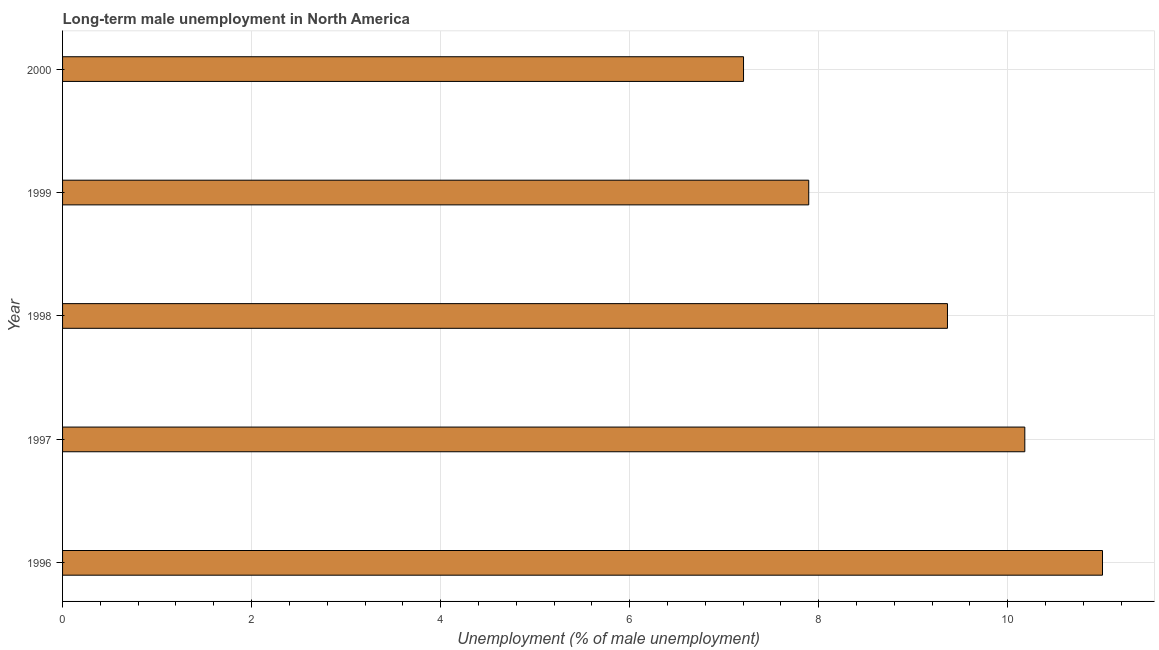Does the graph contain any zero values?
Your answer should be compact. No. What is the title of the graph?
Make the answer very short. Long-term male unemployment in North America. What is the label or title of the X-axis?
Ensure brevity in your answer.  Unemployment (% of male unemployment). What is the label or title of the Y-axis?
Offer a very short reply. Year. What is the long-term male unemployment in 1998?
Your response must be concise. 9.36. Across all years, what is the maximum long-term male unemployment?
Your answer should be compact. 11. Across all years, what is the minimum long-term male unemployment?
Offer a terse response. 7.2. In which year was the long-term male unemployment minimum?
Make the answer very short. 2000. What is the sum of the long-term male unemployment?
Offer a terse response. 45.65. What is the difference between the long-term male unemployment in 1997 and 2000?
Your answer should be very brief. 2.98. What is the average long-term male unemployment per year?
Your response must be concise. 9.13. What is the median long-term male unemployment?
Provide a short and direct response. 9.36. What is the ratio of the long-term male unemployment in 1998 to that in 2000?
Give a very brief answer. 1.3. Is the long-term male unemployment in 1996 less than that in 1997?
Provide a short and direct response. No. What is the difference between the highest and the second highest long-term male unemployment?
Make the answer very short. 0.82. In how many years, is the long-term male unemployment greater than the average long-term male unemployment taken over all years?
Give a very brief answer. 3. Are all the bars in the graph horizontal?
Offer a terse response. Yes. How many years are there in the graph?
Your answer should be very brief. 5. Are the values on the major ticks of X-axis written in scientific E-notation?
Ensure brevity in your answer.  No. What is the Unemployment (% of male unemployment) in 1996?
Offer a very short reply. 11. What is the Unemployment (% of male unemployment) of 1997?
Offer a very short reply. 10.18. What is the Unemployment (% of male unemployment) in 1998?
Your answer should be very brief. 9.36. What is the Unemployment (% of male unemployment) of 1999?
Ensure brevity in your answer.  7.89. What is the Unemployment (% of male unemployment) of 2000?
Offer a very short reply. 7.2. What is the difference between the Unemployment (% of male unemployment) in 1996 and 1997?
Your response must be concise. 0.82. What is the difference between the Unemployment (% of male unemployment) in 1996 and 1998?
Provide a short and direct response. 1.64. What is the difference between the Unemployment (% of male unemployment) in 1996 and 1999?
Give a very brief answer. 3.11. What is the difference between the Unemployment (% of male unemployment) in 1996 and 2000?
Ensure brevity in your answer.  3.8. What is the difference between the Unemployment (% of male unemployment) in 1997 and 1998?
Give a very brief answer. 0.82. What is the difference between the Unemployment (% of male unemployment) in 1997 and 1999?
Offer a very short reply. 2.29. What is the difference between the Unemployment (% of male unemployment) in 1997 and 2000?
Provide a short and direct response. 2.98. What is the difference between the Unemployment (% of male unemployment) in 1998 and 1999?
Give a very brief answer. 1.47. What is the difference between the Unemployment (% of male unemployment) in 1998 and 2000?
Make the answer very short. 2.16. What is the difference between the Unemployment (% of male unemployment) in 1999 and 2000?
Your answer should be very brief. 0.69. What is the ratio of the Unemployment (% of male unemployment) in 1996 to that in 1997?
Make the answer very short. 1.08. What is the ratio of the Unemployment (% of male unemployment) in 1996 to that in 1998?
Provide a succinct answer. 1.18. What is the ratio of the Unemployment (% of male unemployment) in 1996 to that in 1999?
Offer a terse response. 1.39. What is the ratio of the Unemployment (% of male unemployment) in 1996 to that in 2000?
Your answer should be very brief. 1.53. What is the ratio of the Unemployment (% of male unemployment) in 1997 to that in 1998?
Offer a very short reply. 1.09. What is the ratio of the Unemployment (% of male unemployment) in 1997 to that in 1999?
Ensure brevity in your answer.  1.29. What is the ratio of the Unemployment (% of male unemployment) in 1997 to that in 2000?
Keep it short and to the point. 1.41. What is the ratio of the Unemployment (% of male unemployment) in 1998 to that in 1999?
Provide a succinct answer. 1.19. What is the ratio of the Unemployment (% of male unemployment) in 1998 to that in 2000?
Provide a succinct answer. 1.3. What is the ratio of the Unemployment (% of male unemployment) in 1999 to that in 2000?
Ensure brevity in your answer.  1.1. 